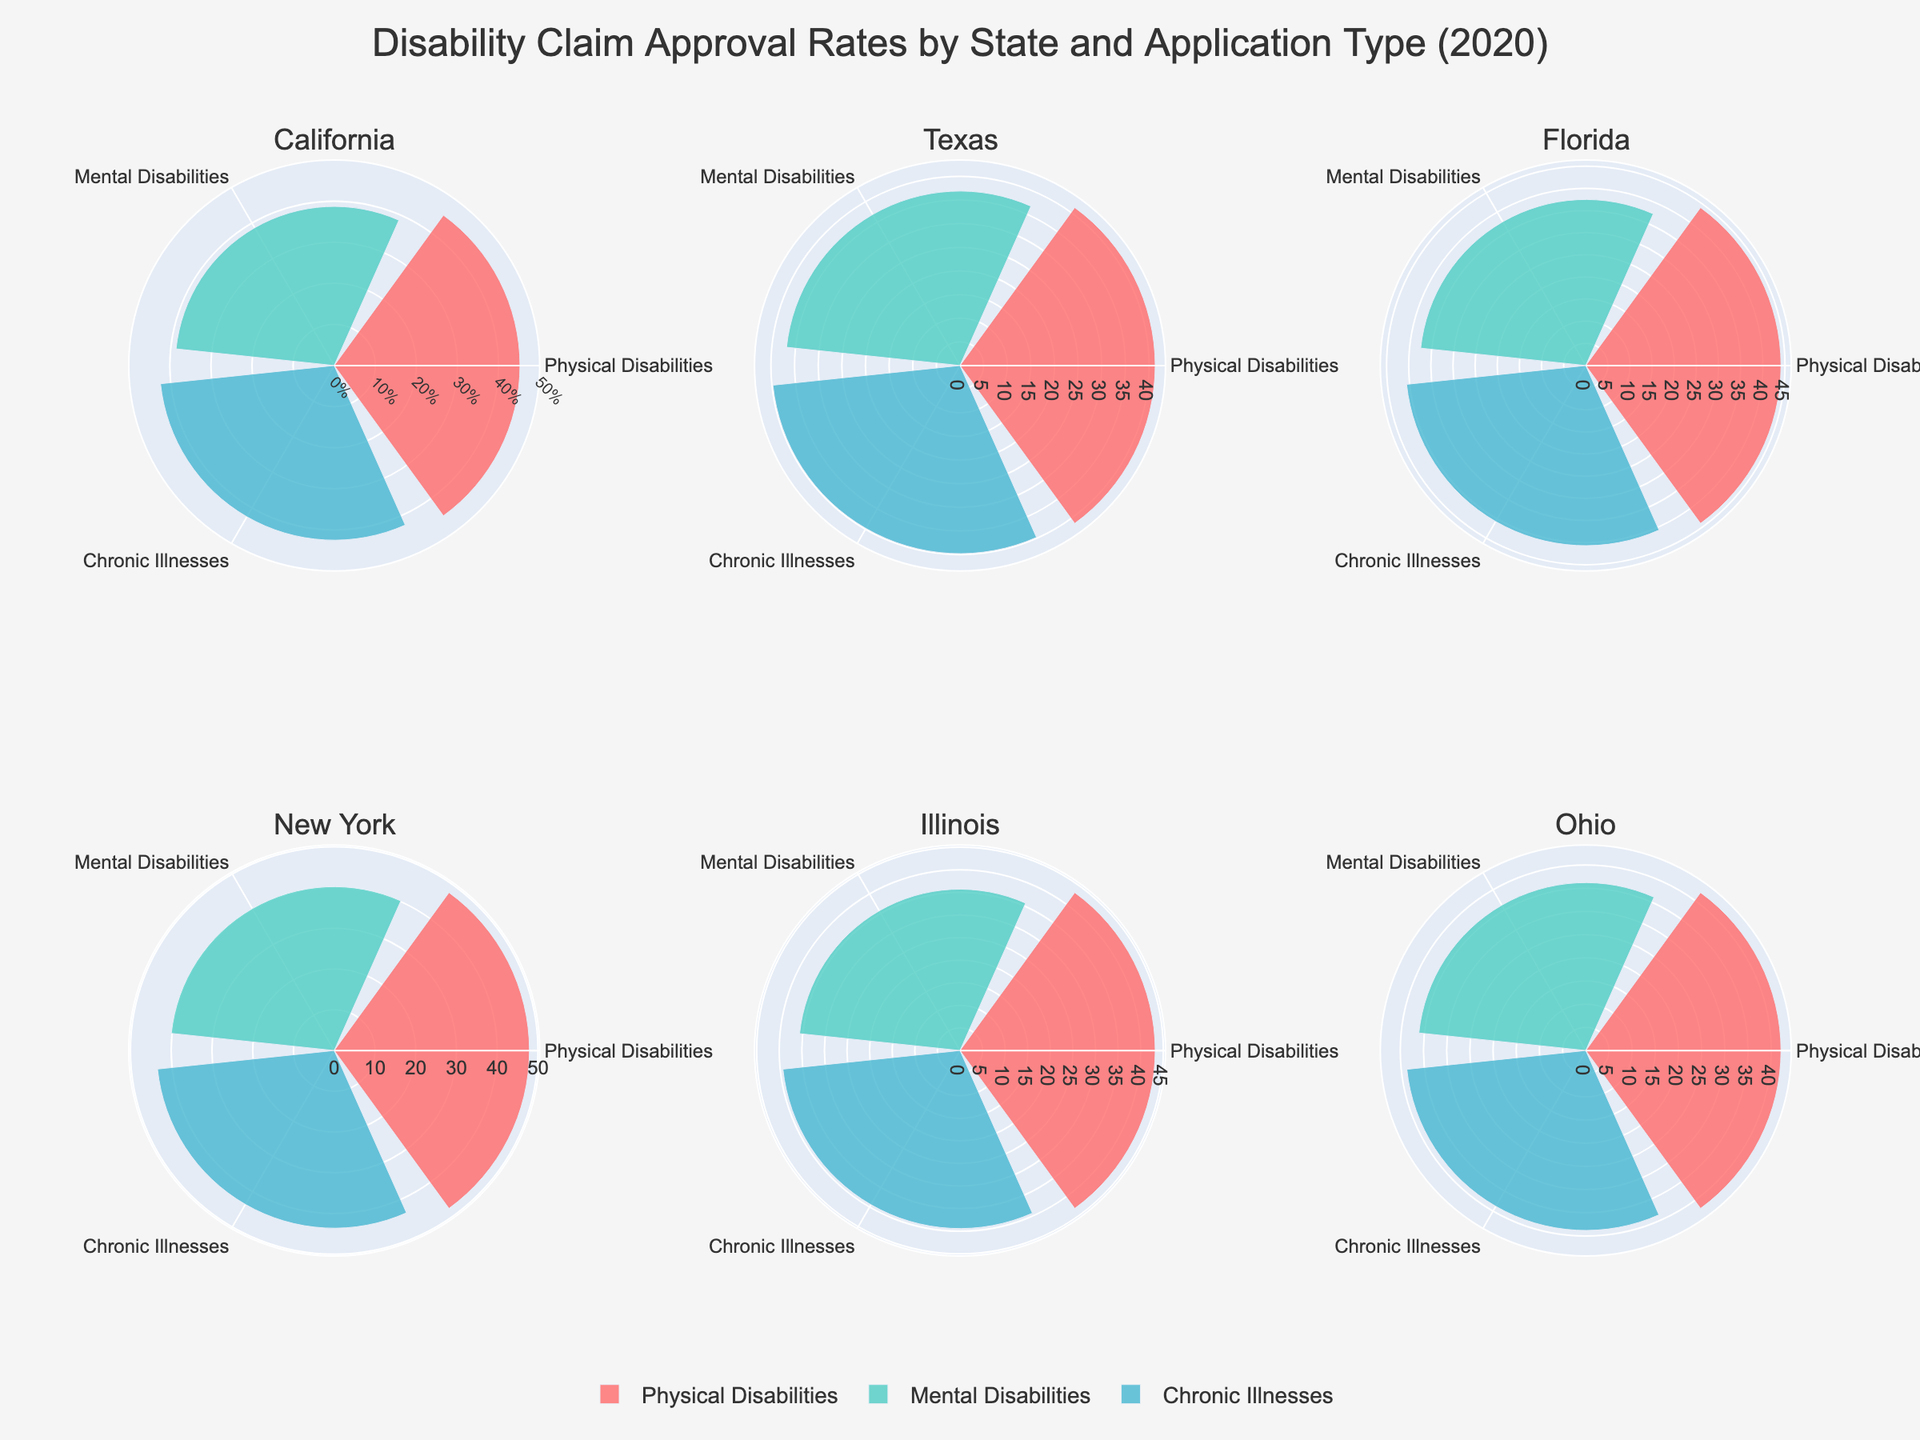How are the approval rates for physical disabilities represented in California? The approval rate for physical disabilities in California is shown in the top left subplot with a bar extending to 45.2% in the rose chart for the segment labeled "Physical Disabilities".
Answer: 45.2% Which state has the highest approval rate for mental disabilities? New York has the highest approval rate for mental disabilities, shown by a bar reaching 40.2% for the segment labeled "Mental Disabilities".
Answer: New York Compare the approval rates for chronic illnesses between Texas and Ohio. In the subplots for Texas and Ohio, the approval rates for chronic illnesses are shown with bars reaching 39.8% and 38.8%, respectively. Thus, Texas has a higher approval rate for chronic illnesses.
Answer: Texas What is the average approval rate for mental disabilities across all states? To find the average approval rate for mental disabilities, sum the approval rates for mental disabilities in all states (38.7 + 36.9 + 37.5 + 40.2 + 35.7 + 36.2 = 225.2) and divide by the number of states (6). The average is thus 225.2 / 6 ≈ 37.5
Answer: 37.5% Which state has the smallest difference in approval rates between physical disabilities and mental disabilities? The difference for each state are: 
California: 45.2 - 38.7 = 6.5, Texas: 41.3 - 36.9 = 4.4, Florida: 44.1 - 37.5 = 6.6, New York: 47.9 - 40.2 = 7.7, Illinois: 43.2 - 35.7 = 7.5, Ohio: 42.1 - 36.2 = 5.9. The smallest difference is found in Texas with 4.4.
Answer: Texas How do the approval rates for physical disabilities vary across the displayed states? Approval rates for physical disabilities are as follows: California - 45.2%, Texas - 41.3%, Florida - 44.1%, New York - 47.9%, Illinois - 43.2%, Ohio - 42.1%. This range from 41.3% to 47.9% shows variability with New York having the highest rate and Texas having the lowest.
Answer: Varies from 41.3% to 47.9% What is the maximum approval rate shown in the charts? The highest approval rate depicted in all the subplots is 47.9% for physical disabilities in New York, as indicated by the longest bar in the respective segment.
Answer: 47.9% What is the overall trend in approval rates for chronic illnesses among these states? By examining each subplot, it can be observed that the approval rates for chronic illnesses range from 38.8% in Ohio to 43.6% in New York. The trend shows moderate variability but remains within a fairly narrow band, without extreme highs or lows.
Answer: Moderate variability (38.8% to 43.6%) 